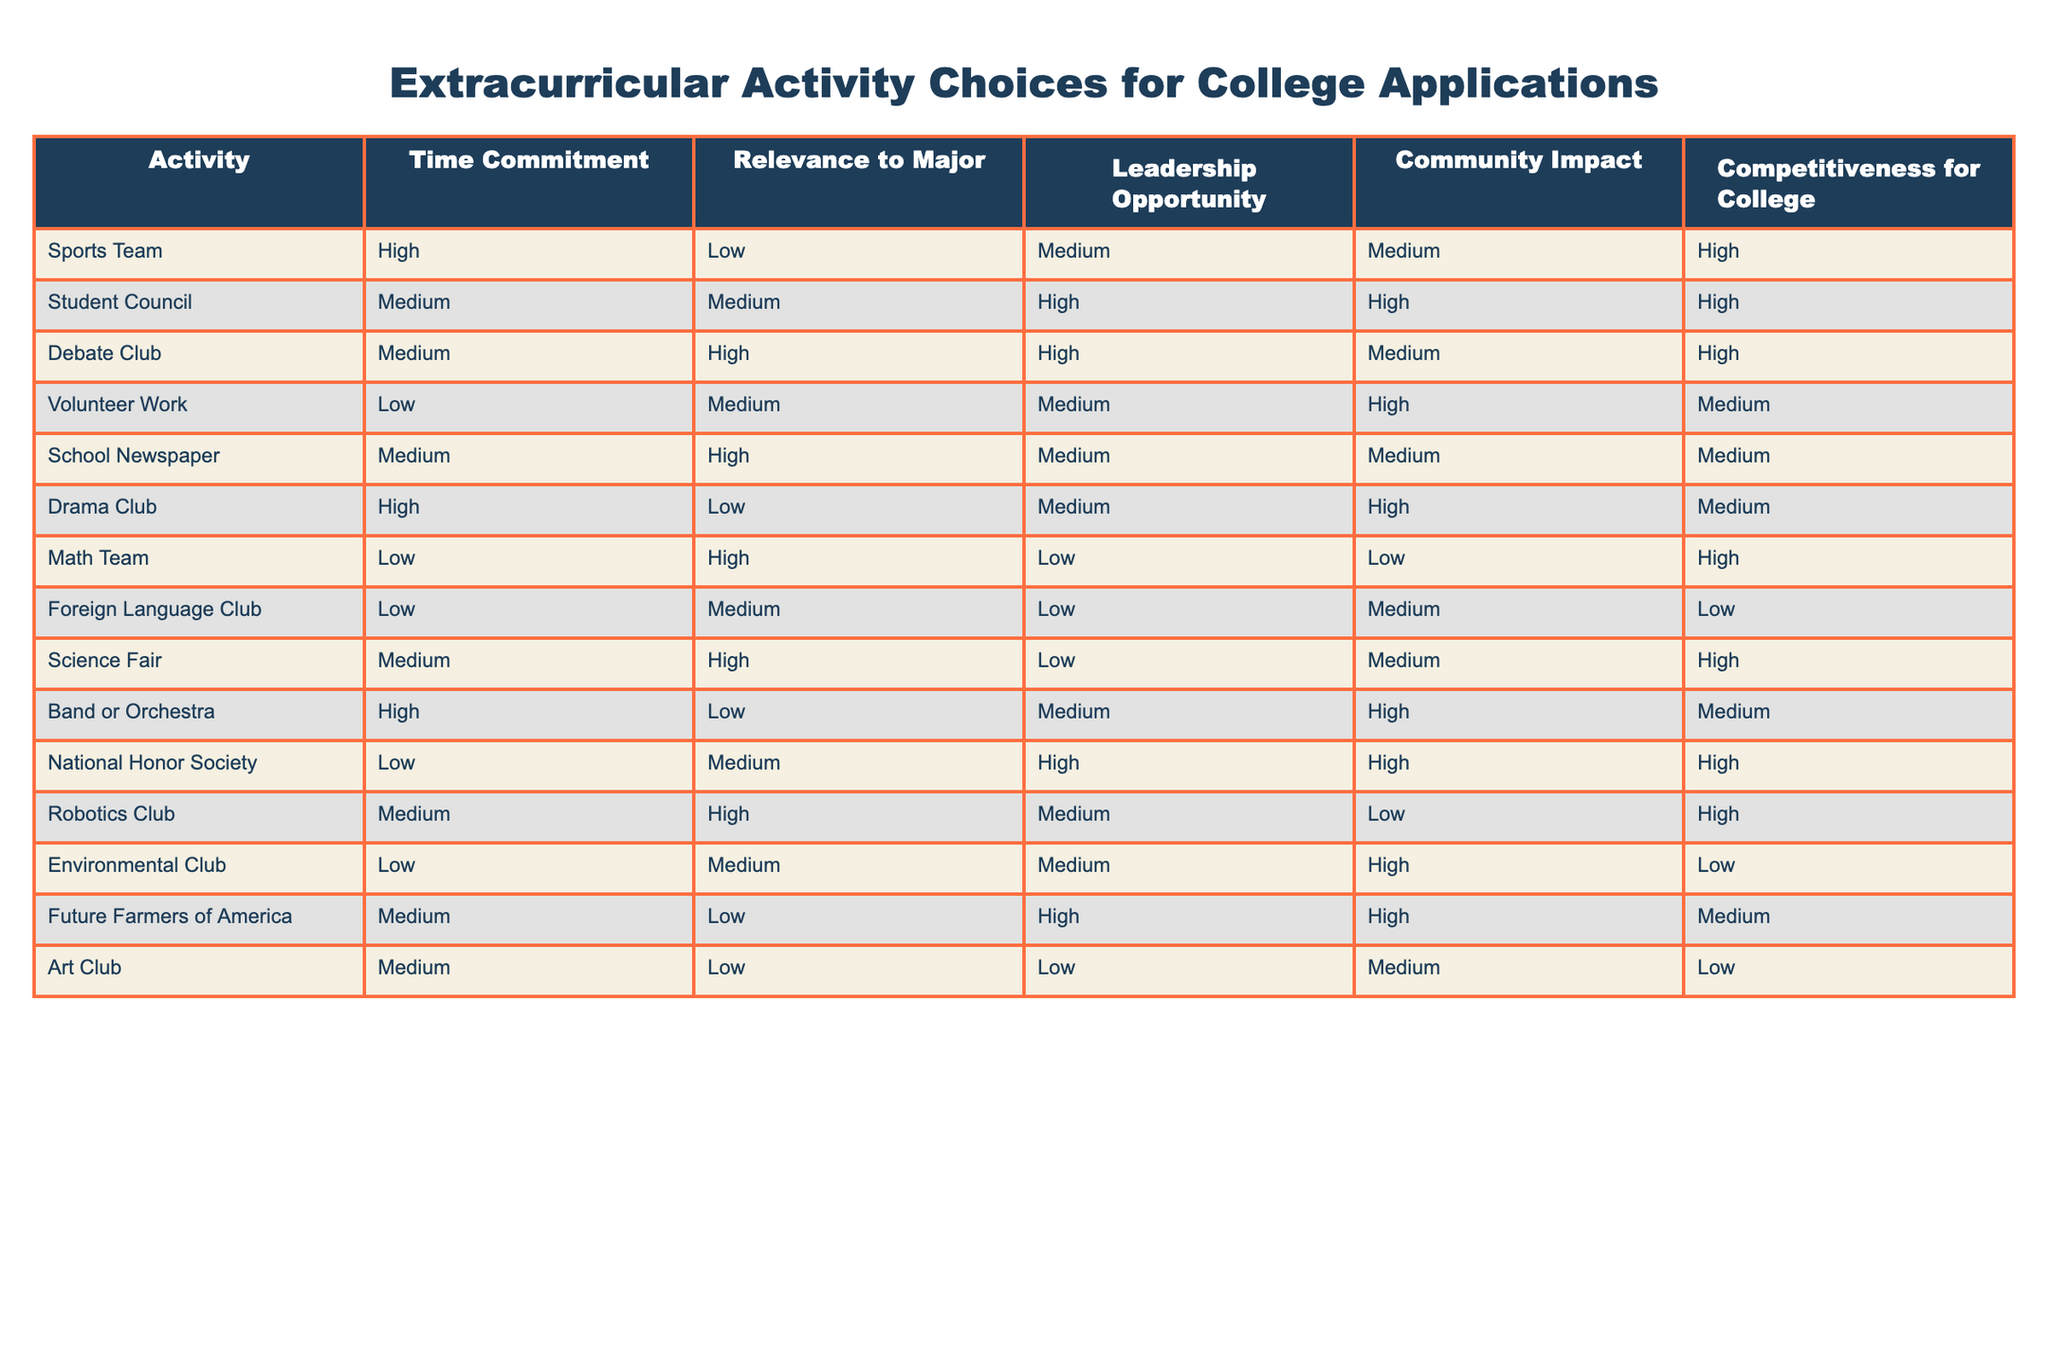What is the time commitment for the Drama Club? The table shows that the time commitment for the Drama Club is categorized as "High."
Answer: High Which activity has the highest leadership opportunity? By examining the "Leadership Opportunity" column, both the Student Council and Future Farmers of America have a "High" rating, making them the activities with the highest opportunities for leadership.
Answer: Student Council and Future Farmers of America What is the average competitiveness rating for activities that have a low relevance to major? From the table, the activities with a low relevance to major include Sports Team, Drama Club, Band or Orchestra, Math Team, Foreign Language Club, Environmental Club, and Art Club. Their respective competitiveness ratings are High, Medium, Medium, High, Low, Low, and Low. By converting these to a numerical scale (High = 3, Medium = 2, Low = 1), we calculate: (3 + 2 + 2 + 3 + 1 + 1 + 1) / 7 = 1.714, which we round to 1.71.
Answer: 1.71 Is it true that all extracurricular activities with high competitiveness have a medium or high community impact? Analyzing the table, we see the activities with high competitiveness (Sports Team, Student Council, Debate Club, Math Team, Science Fair, Robotics Club) have varying community impact ratings. Notably, Math Team has a "Low" community impact, which contradicts the statement. Thus, it is false.
Answer: No Which activity has a medium time commitment but does not provide a leadership opportunity? According to the table, the activities with a medium time commitment are Student Council, Debate Club, School Newspaper, Drama Club, and Robotics Club. Among these, the School Newspaper has a "Medium" rating for leadership opportunity, thus the answer is the Drama Club, which is also at medium time commitment but does not provide a high leadership opportunity (it's rated medium).
Answer: Drama Club 